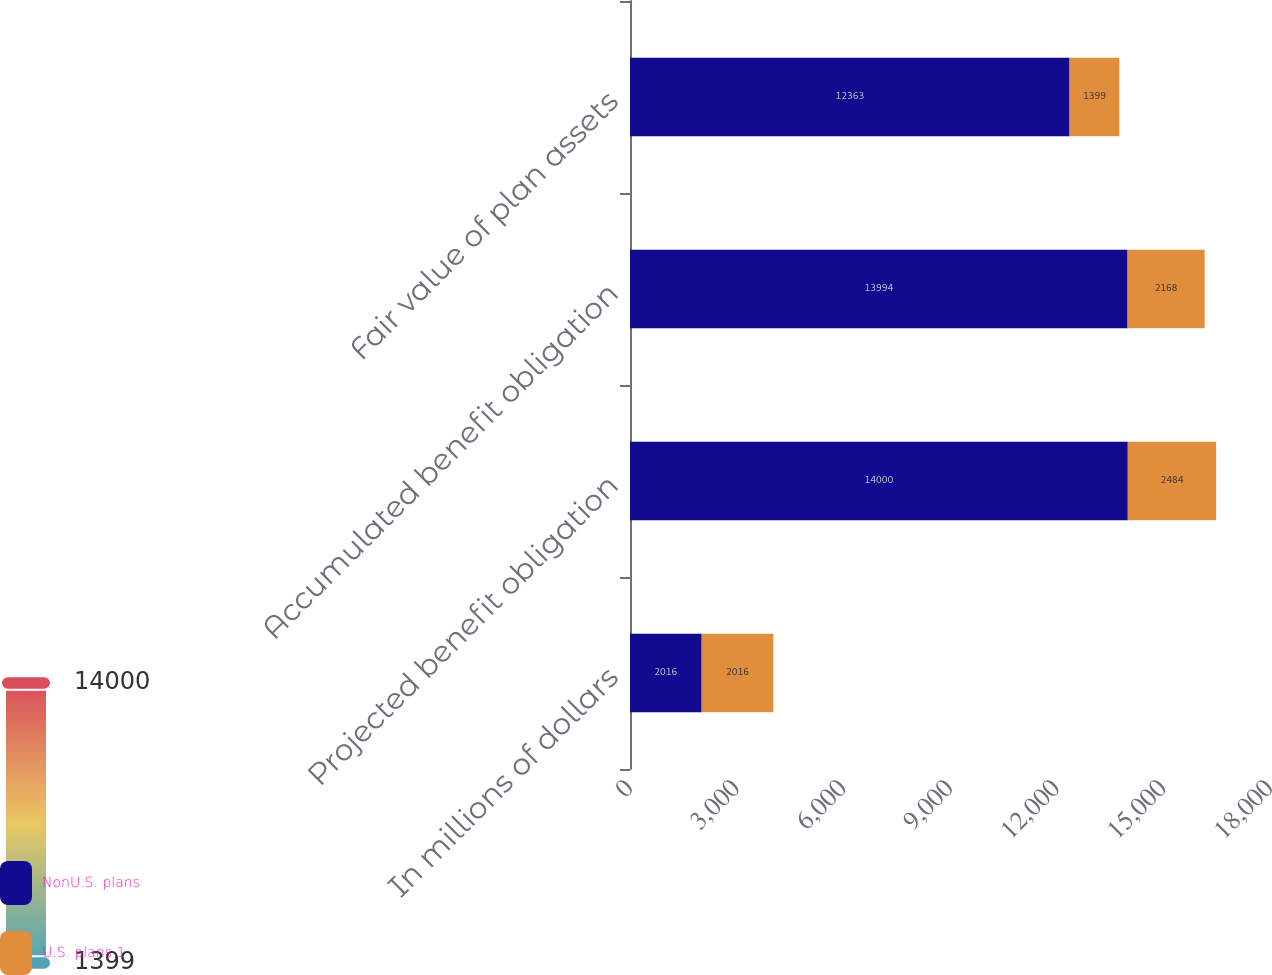Convert chart. <chart><loc_0><loc_0><loc_500><loc_500><stacked_bar_chart><ecel><fcel>In millions of dollars<fcel>Projected benefit obligation<fcel>Accumulated benefit obligation<fcel>Fair value of plan assets<nl><fcel>NonU.S. plans<fcel>2016<fcel>14000<fcel>13994<fcel>12363<nl><fcel>U.S. plans 1<fcel>2016<fcel>2484<fcel>2168<fcel>1399<nl></chart> 